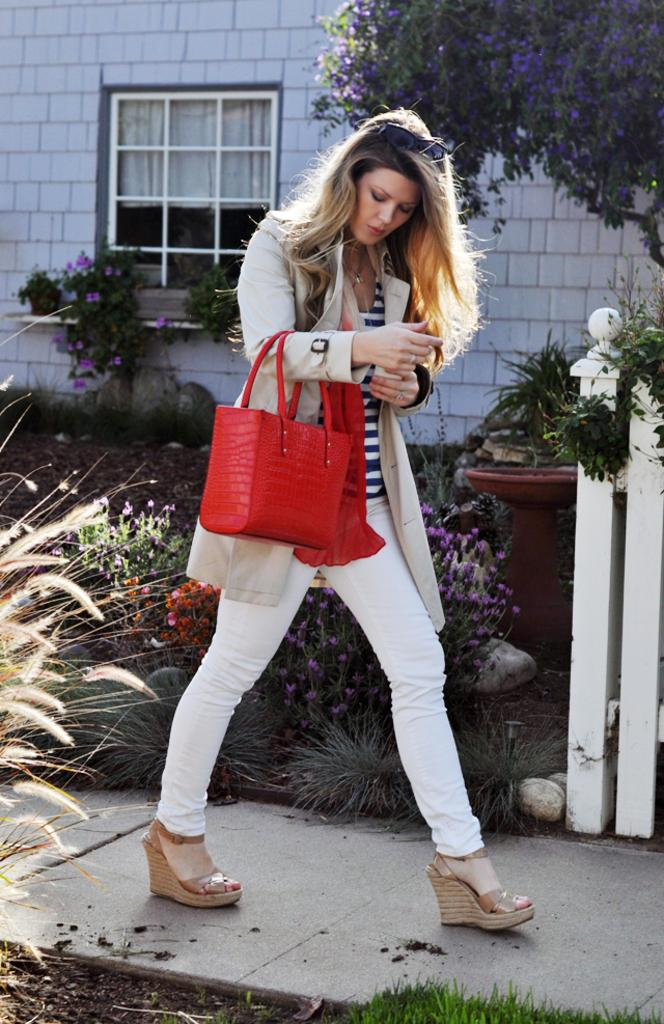Who is present in the image? There is a woman in the image. What is the woman holding in the image? The woman is holding a red color bag. What is the woman doing in the image? The woman is walking. What can be seen in the background of the image? There is a tree, a building, and plants in the background of the image. What type of kettle can be seen in the woman's hand in the image? There is no kettle present in the image; the woman is holding a red color bag. 